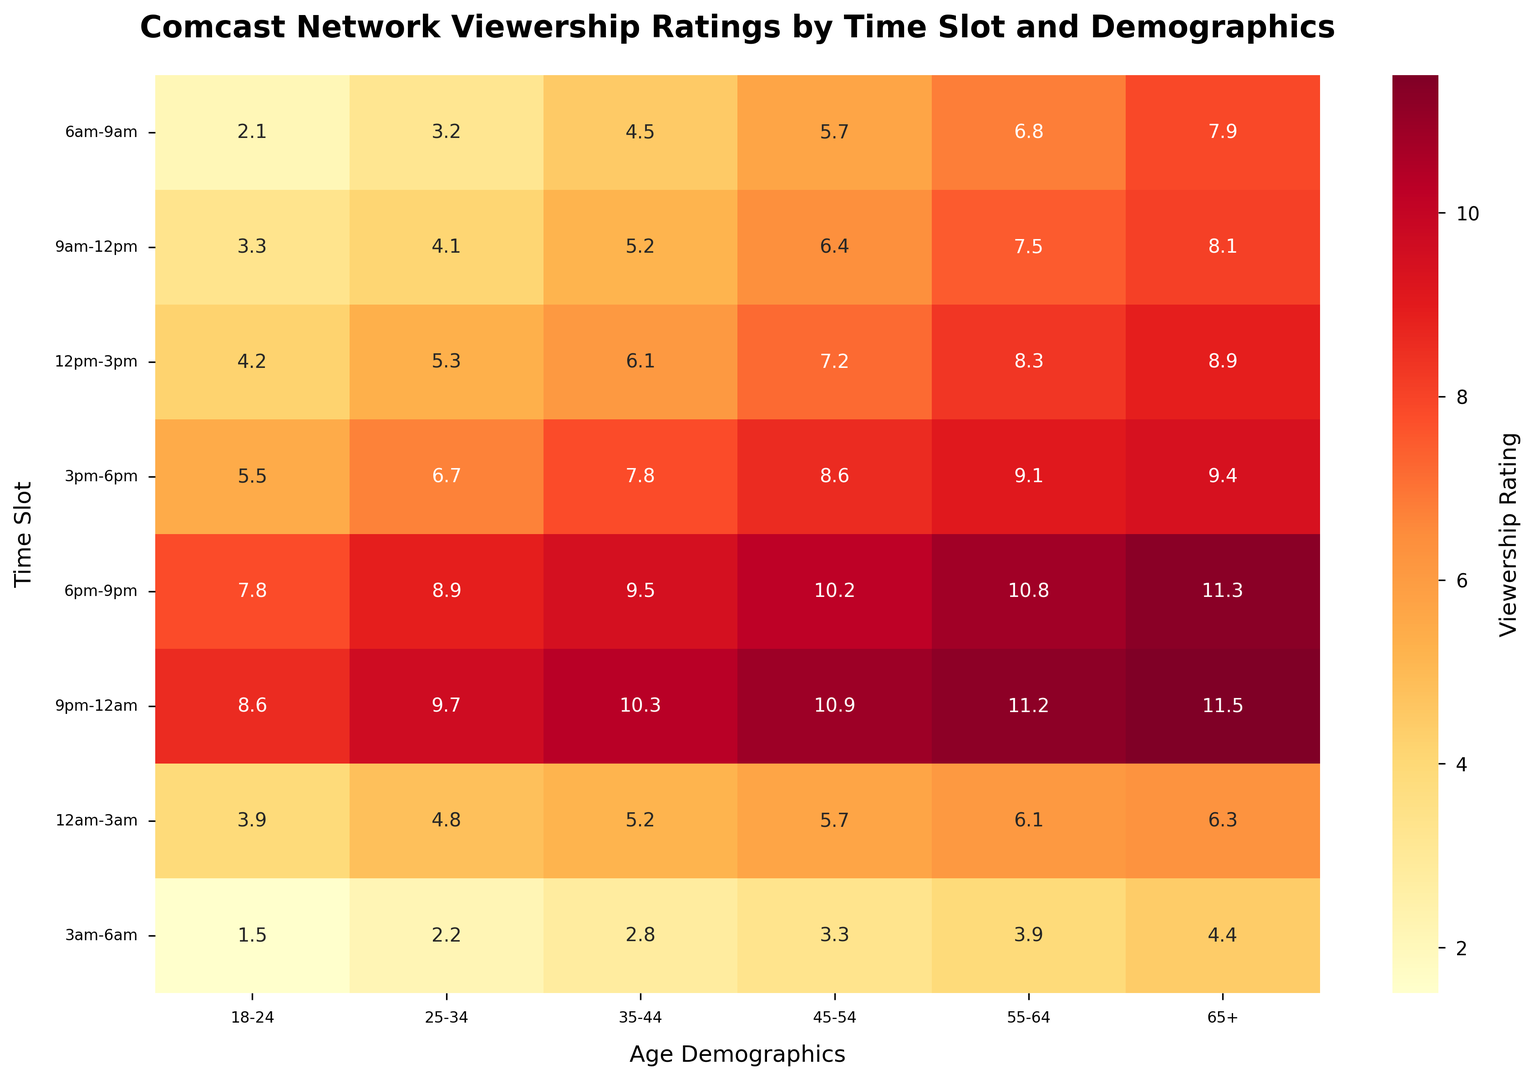Which time slot has the highest viewership rating for the age group 18-24? Observing the colors and annotations in the 18-24 column, the highest rating is at the 9pm-12am time slot.
Answer: 9pm-12am Which age group has the lowest viewership rating in the 3pm-6pm time slot? By looking at the 3pm-6pm row, the lowest rating is found in the 18-24 age group.
Answer: 18-24 What is the difference in viewership ratings between the 18-24 and 65+ age groups for the 6pm-9pm time slot? The rating for 18-24 is 7.8 and for 65+ is 11.3. Subtracting these gives 11.3 - 7.8 = 3.5.
Answer: 3.5 Which age group shows the largest increase in viewership from 6am-9am to 9am-12pm? Calculating the difference for each age group: 
  - 18-24: 3.3 - 2.1 = 1.2 
  - 25-34: 4.1 - 3.2 = 0.9
  - 35-44: 5.2 - 4.5 = 0.7
  - 45-54: 6.4 - 5.7 = 0.7
  - 55-64: 7.5 - 6.8 = 0.7
  - 65+: 8.1 - 7.9 = 0.2
  
The 18-24 age group has the largest increase of 1.2.
Answer: 18-24 Is the viewership rating for the 25-34 age group higher or lower in the 12am-3am time slot compared to the 3am-6am time slot? The rating in 12am-3am is 4.8, which is higher than the 2.2 rating in 3am-6am.
Answer: Higher What is the average viewership rating for the 45-54 age group across all time slots? Sum up the ratings for 45-54: 
5.7 + 6.4 + 7.2 + 8.6 + 10.2 + 10.9 + 5.7 + 3.3 = 57.0 
Divide by 8 time slots: 
57.0 / 8 = 7.125.
Answer: 7.1 Which time slot has the most uniform viewership ratings across all age groups? Uniformity can be seen by checking the variation in ratings across age groups. The 9pm-12am time slot ratings are closest (8.6 to 11.5) compared to others.
Answer: 9pm-12am By how much does the viewership rating change from 12pm-3pm to 6pm-9pm for the 55-64 age group? Rating at 6pm-9pm for the 55-64 is 10.8 and at 12pm-3pm is 8.3. The difference is 10.8 - 8.3 = 2.5.
Answer: 2.5 